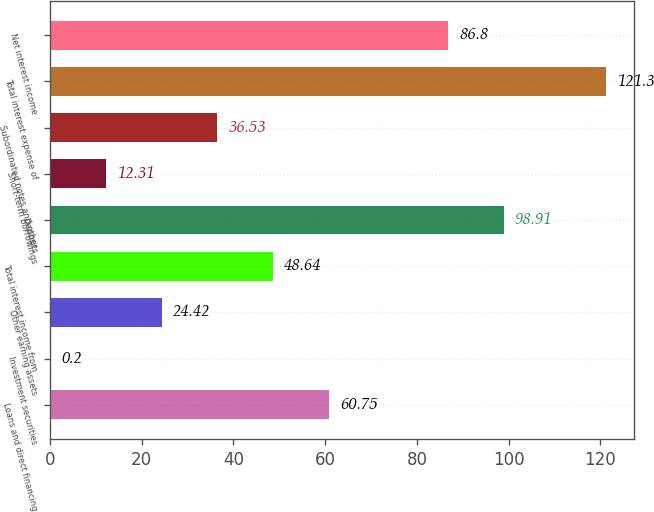Convert chart. <chart><loc_0><loc_0><loc_500><loc_500><bar_chart><fcel>Loans and direct financing<fcel>Investment securities<fcel>Other earning assets<fcel>Total interest income from<fcel>Deposits<fcel>Short-term borrowings<fcel>Subordinated notes and other<fcel>Total interest expense of<fcel>Net interest income<nl><fcel>60.75<fcel>0.2<fcel>24.42<fcel>48.64<fcel>98.91<fcel>12.31<fcel>36.53<fcel>121.3<fcel>86.8<nl></chart> 